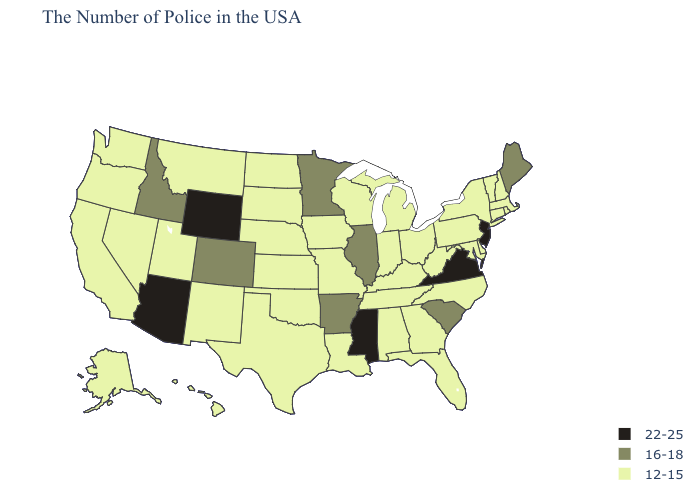Name the states that have a value in the range 12-15?
Be succinct. Massachusetts, Rhode Island, New Hampshire, Vermont, Connecticut, New York, Delaware, Maryland, Pennsylvania, North Carolina, West Virginia, Ohio, Florida, Georgia, Michigan, Kentucky, Indiana, Alabama, Tennessee, Wisconsin, Louisiana, Missouri, Iowa, Kansas, Nebraska, Oklahoma, Texas, South Dakota, North Dakota, New Mexico, Utah, Montana, Nevada, California, Washington, Oregon, Alaska, Hawaii. Name the states that have a value in the range 16-18?
Give a very brief answer. Maine, South Carolina, Illinois, Arkansas, Minnesota, Colorado, Idaho. Which states have the highest value in the USA?
Give a very brief answer. New Jersey, Virginia, Mississippi, Wyoming, Arizona. What is the lowest value in the South?
Quick response, please. 12-15. Which states hav the highest value in the South?
Short answer required. Virginia, Mississippi. Is the legend a continuous bar?
Concise answer only. No. Name the states that have a value in the range 16-18?
Keep it brief. Maine, South Carolina, Illinois, Arkansas, Minnesota, Colorado, Idaho. Does the first symbol in the legend represent the smallest category?
Quick response, please. No. Which states have the highest value in the USA?
Keep it brief. New Jersey, Virginia, Mississippi, Wyoming, Arizona. How many symbols are there in the legend?
Keep it brief. 3. Which states have the lowest value in the MidWest?
Quick response, please. Ohio, Michigan, Indiana, Wisconsin, Missouri, Iowa, Kansas, Nebraska, South Dakota, North Dakota. Among the states that border North Dakota , which have the highest value?
Quick response, please. Minnesota. Name the states that have a value in the range 16-18?
Short answer required. Maine, South Carolina, Illinois, Arkansas, Minnesota, Colorado, Idaho. Name the states that have a value in the range 12-15?
Concise answer only. Massachusetts, Rhode Island, New Hampshire, Vermont, Connecticut, New York, Delaware, Maryland, Pennsylvania, North Carolina, West Virginia, Ohio, Florida, Georgia, Michigan, Kentucky, Indiana, Alabama, Tennessee, Wisconsin, Louisiana, Missouri, Iowa, Kansas, Nebraska, Oklahoma, Texas, South Dakota, North Dakota, New Mexico, Utah, Montana, Nevada, California, Washington, Oregon, Alaska, Hawaii. 